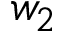<formula> <loc_0><loc_0><loc_500><loc_500>w _ { 2 }</formula> 